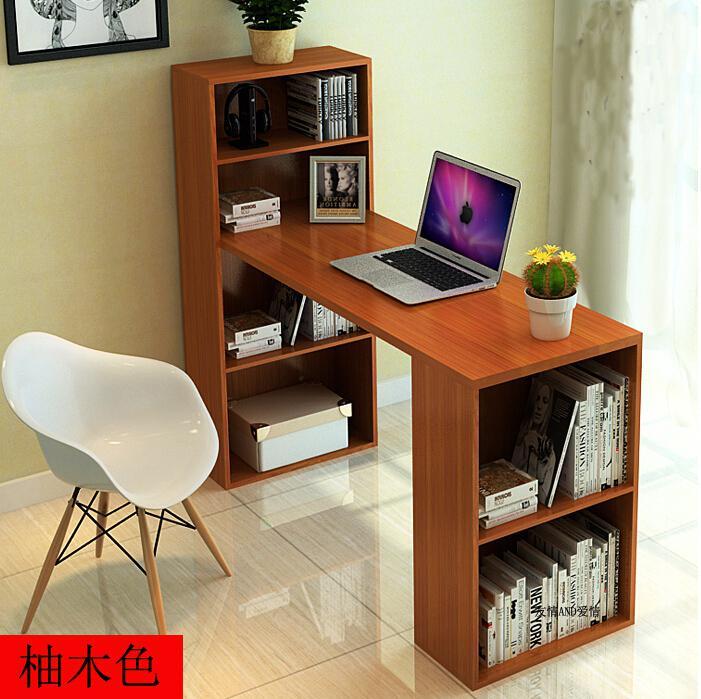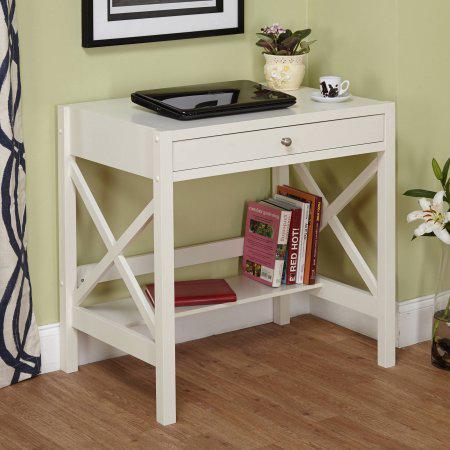The first image is the image on the left, the second image is the image on the right. Given the left and right images, does the statement "Both sides of the desk are actually book shelves." hold true? Answer yes or no. Yes. The first image is the image on the left, the second image is the image on the right. Assess this claim about the two images: "There is a total of 1 flower-less, green, leafy plant sitting to the right of a laptop screen.". Correct or not? Answer yes or no. No. 